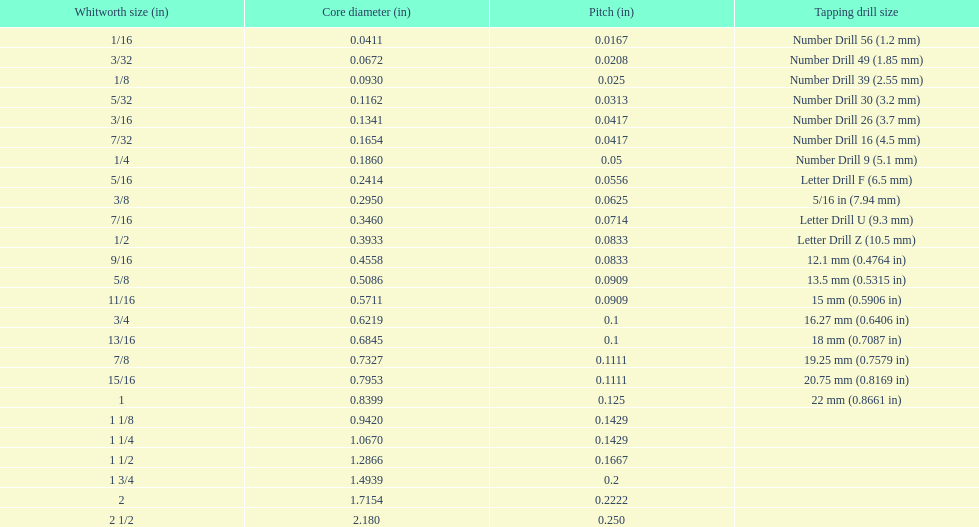0930? 0.1162. 